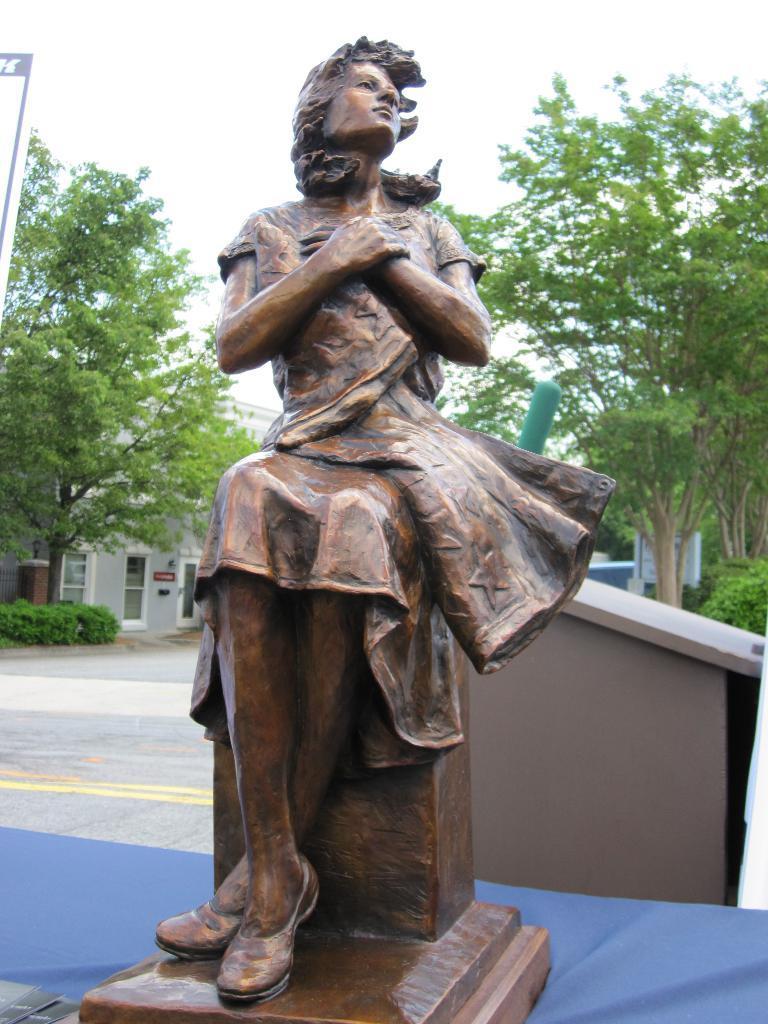In one or two sentences, can you explain what this image depicts? In the center of the image there is a statue. In the background we can see dustbin, trees, buildings, road and sky. 